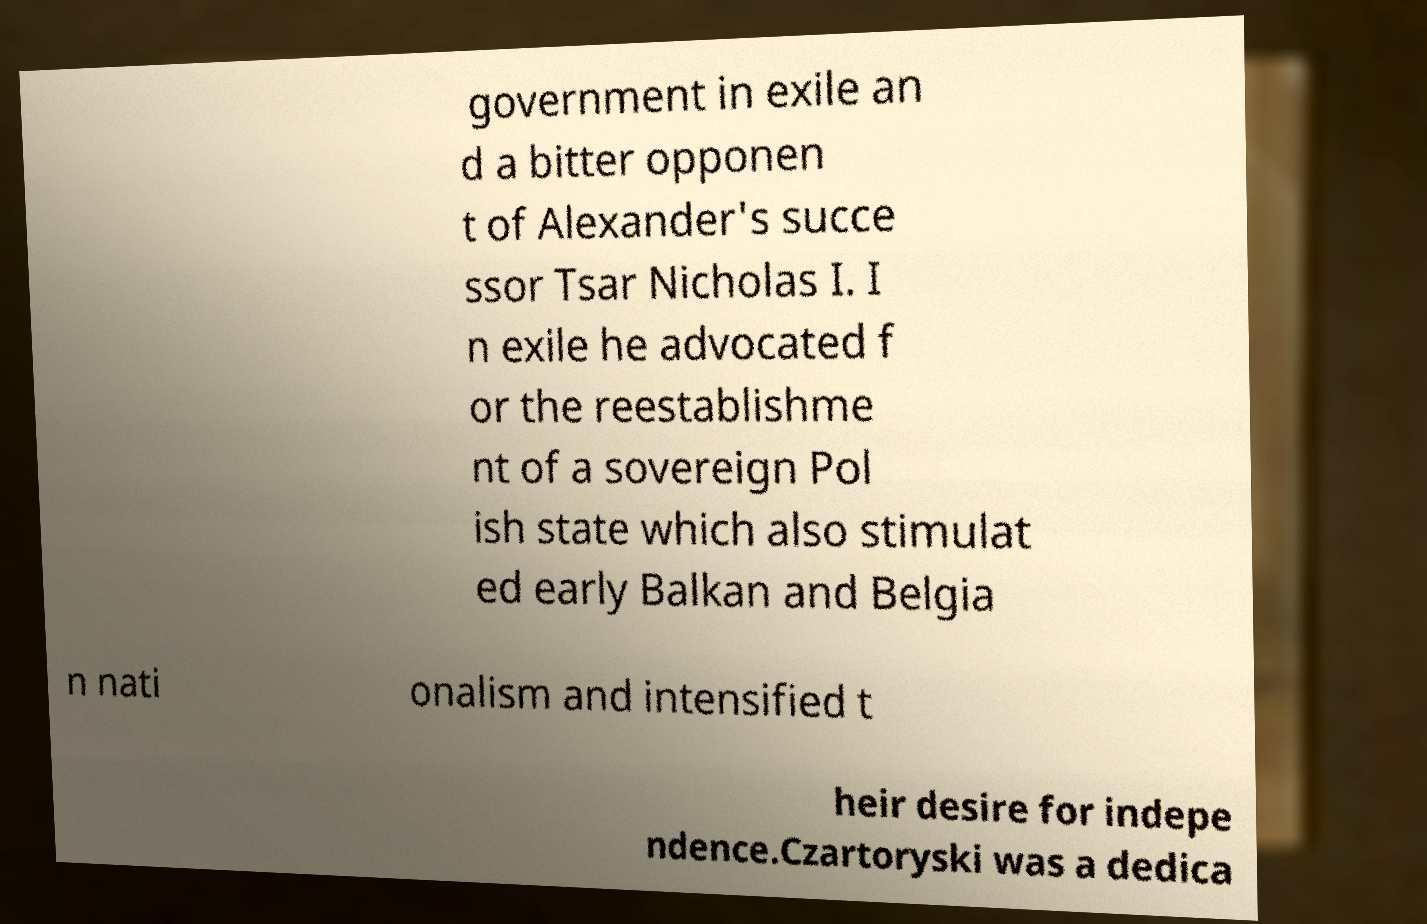Could you assist in decoding the text presented in this image and type it out clearly? government in exile an d a bitter opponen t of Alexander's succe ssor Tsar Nicholas I. I n exile he advocated f or the reestablishme nt of a sovereign Pol ish state which also stimulat ed early Balkan and Belgia n nati onalism and intensified t heir desire for indepe ndence.Czartoryski was a dedica 